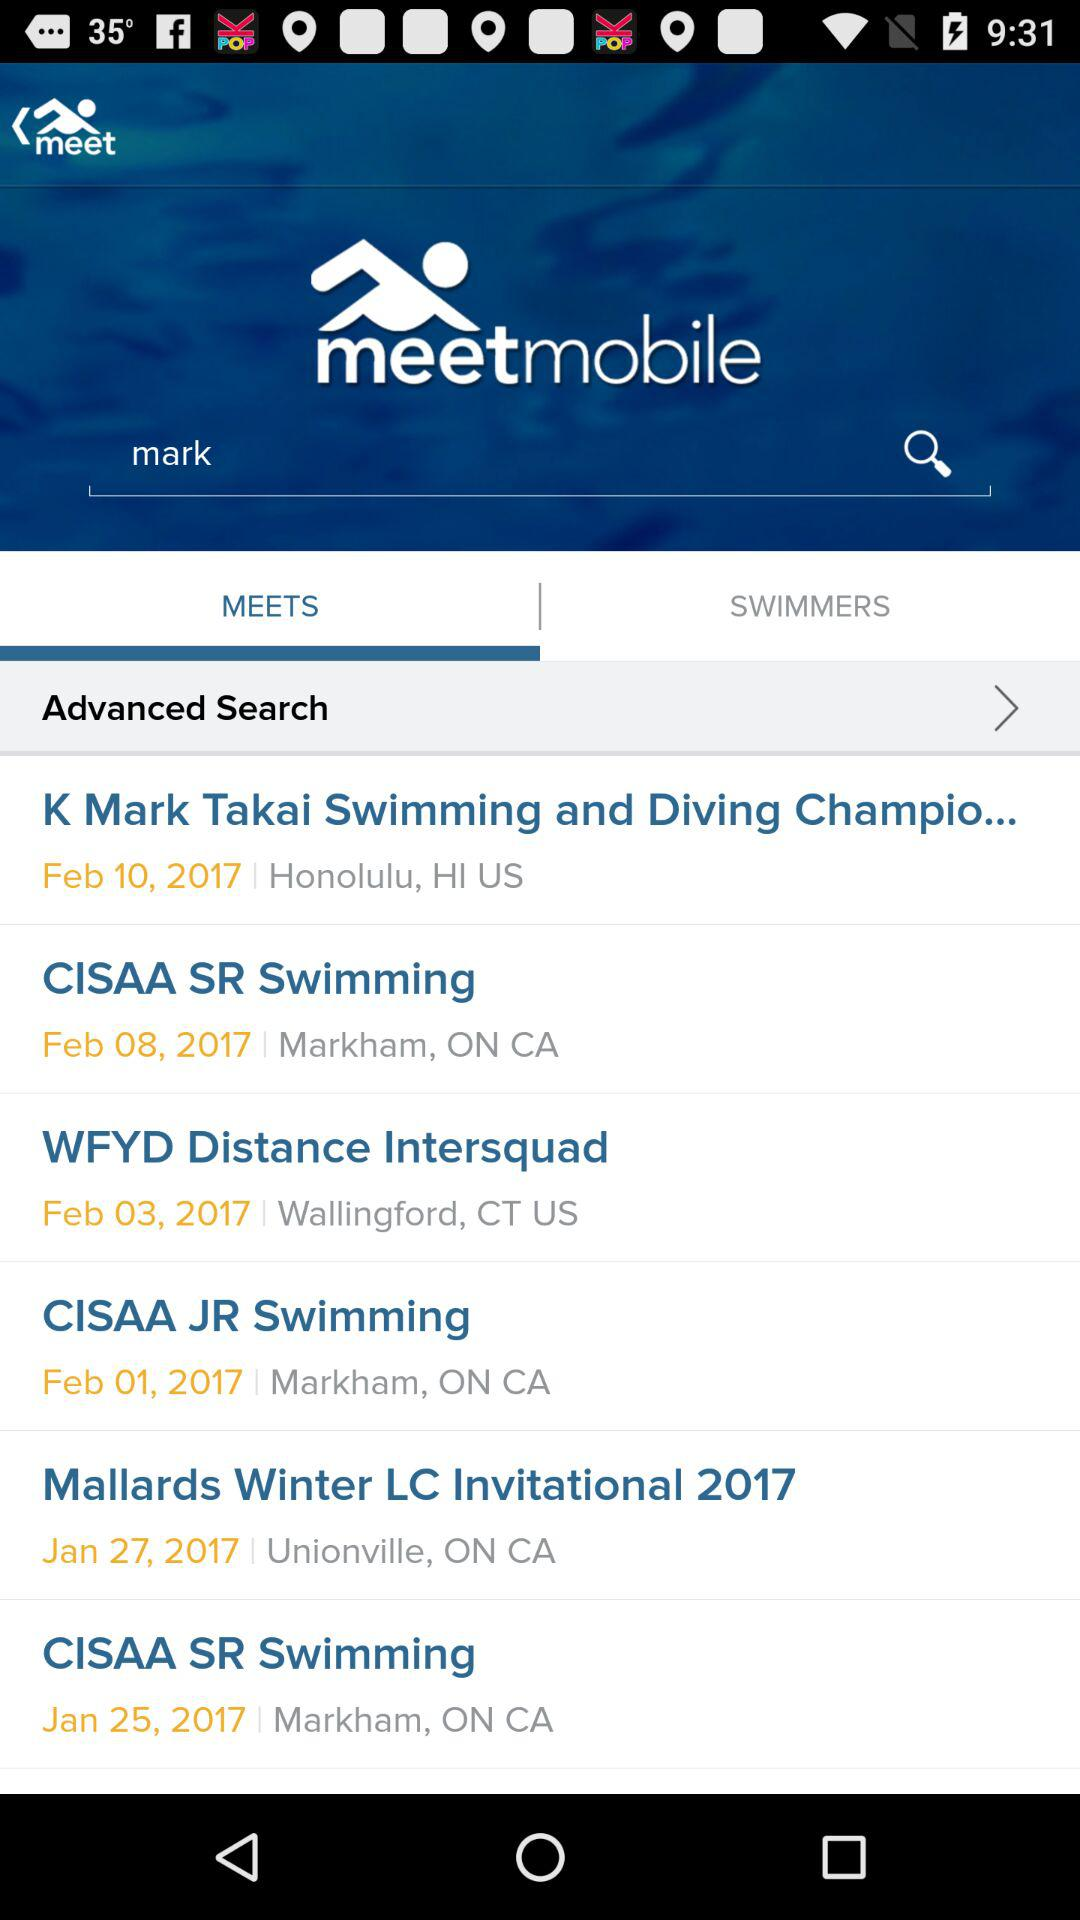Which tab is selected right now? The selected tab is "MEETS". 